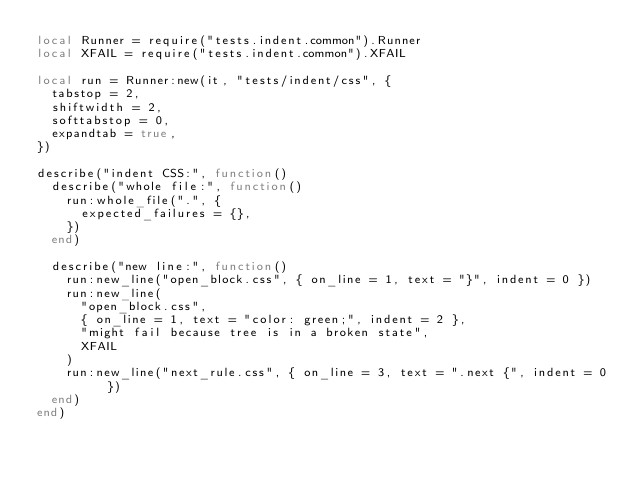Convert code to text. <code><loc_0><loc_0><loc_500><loc_500><_Lua_>local Runner = require("tests.indent.common").Runner
local XFAIL = require("tests.indent.common").XFAIL

local run = Runner:new(it, "tests/indent/css", {
  tabstop = 2,
  shiftwidth = 2,
  softtabstop = 0,
  expandtab = true,
})

describe("indent CSS:", function()
  describe("whole file:", function()
    run:whole_file(".", {
      expected_failures = {},
    })
  end)

  describe("new line:", function()
    run:new_line("open_block.css", { on_line = 1, text = "}", indent = 0 })
    run:new_line(
      "open_block.css",
      { on_line = 1, text = "color: green;", indent = 2 },
      "might fail because tree is in a broken state",
      XFAIL
    )
    run:new_line("next_rule.css", { on_line = 3, text = ".next {", indent = 0 })
  end)
end)
</code> 